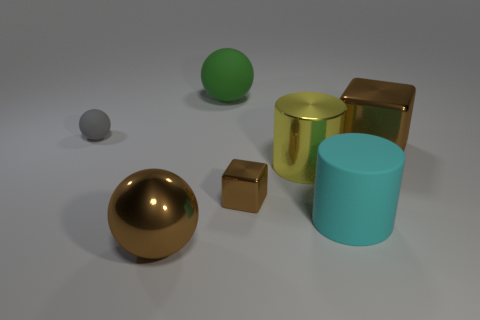Subtract all rubber spheres. How many spheres are left? 1 Add 1 red matte balls. How many objects exist? 8 Subtract all spheres. How many objects are left? 4 Subtract 0 green blocks. How many objects are left? 7 Subtract all small green metal cubes. Subtract all cyan cylinders. How many objects are left? 6 Add 1 big matte cylinders. How many big matte cylinders are left? 2 Add 4 large cyan rubber cylinders. How many large cyan rubber cylinders exist? 5 